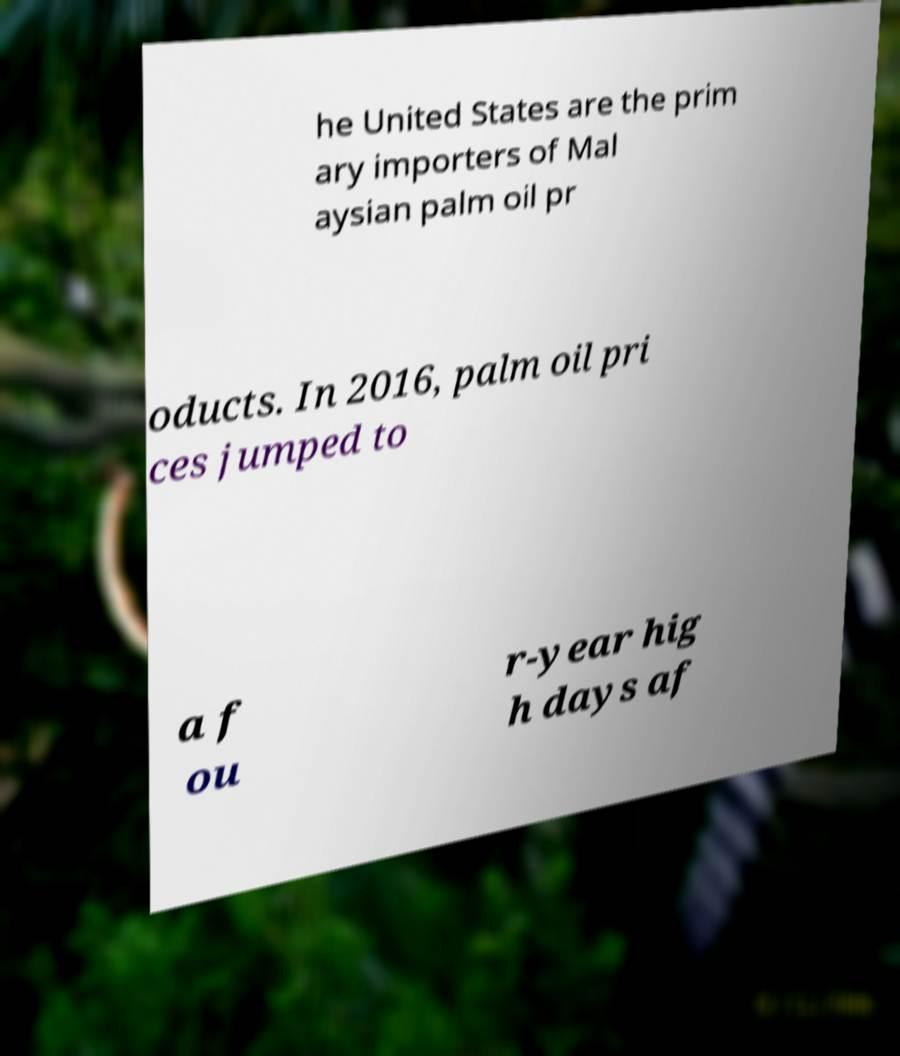For documentation purposes, I need the text within this image transcribed. Could you provide that? he United States are the prim ary importers of Mal aysian palm oil pr oducts. In 2016, palm oil pri ces jumped to a f ou r-year hig h days af 